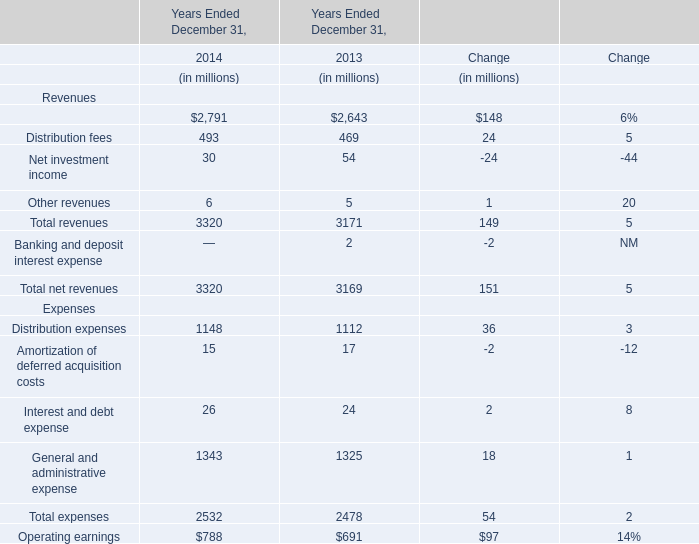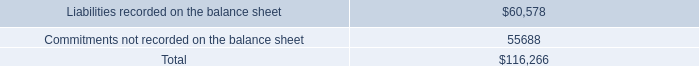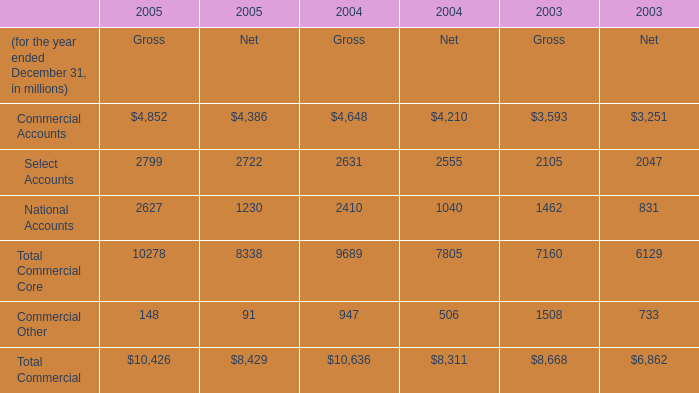What is the sum of Commercial Accounts of 2005 Gross, Liabilities recorded on the balance sheet, and Total Commercial of 2004 Net ? 
Computations: ((4852.0 + 60578.0) + 8311.0)
Answer: 73741.0. 